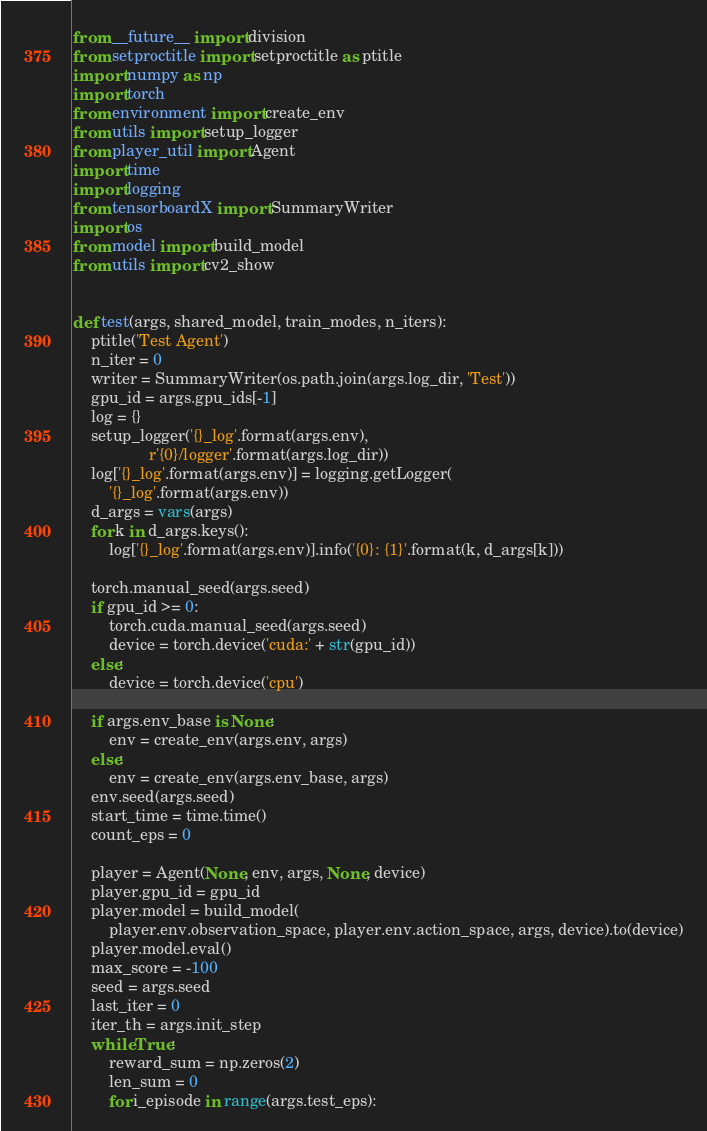Convert code to text. <code><loc_0><loc_0><loc_500><loc_500><_Python_>from __future__ import division
from setproctitle import setproctitle as ptitle
import numpy as np
import torch
from environment import create_env
from utils import setup_logger
from player_util import Agent
import time
import logging
from tensorboardX import SummaryWriter
import os
from model import build_model
from utils import cv2_show


def test(args, shared_model, train_modes, n_iters):
    ptitle('Test Agent')
    n_iter = 0
    writer = SummaryWriter(os.path.join(args.log_dir, 'Test'))
    gpu_id = args.gpu_ids[-1]
    log = {}
    setup_logger('{}_log'.format(args.env),
                 r'{0}/logger'.format(args.log_dir))
    log['{}_log'.format(args.env)] = logging.getLogger(
        '{}_log'.format(args.env))
    d_args = vars(args)
    for k in d_args.keys():
        log['{}_log'.format(args.env)].info('{0}: {1}'.format(k, d_args[k]))

    torch.manual_seed(args.seed)
    if gpu_id >= 0:
        torch.cuda.manual_seed(args.seed)
        device = torch.device('cuda:' + str(gpu_id))
    else:
        device = torch.device('cpu')

    if args.env_base is None:
        env = create_env(args.env, args)
    else:
        env = create_env(args.env_base, args)
    env.seed(args.seed)
    start_time = time.time()
    count_eps = 0

    player = Agent(None, env, args, None, device)
    player.gpu_id = gpu_id
    player.model = build_model(
        player.env.observation_space, player.env.action_space, args, device).to(device)
    player.model.eval()
    max_score = -100
    seed = args.seed
    last_iter = 0
    iter_th = args.init_step
    while True:
        reward_sum = np.zeros(2)
        len_sum = 0
        for i_episode in range(args.test_eps):</code> 